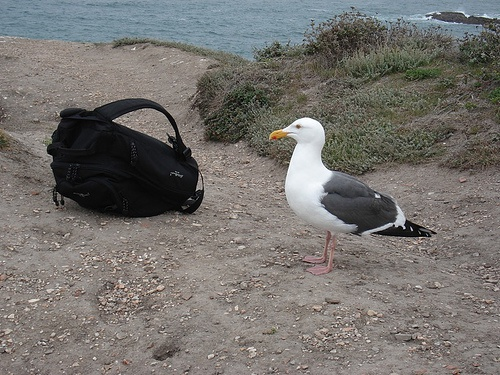Describe the objects in this image and their specific colors. I can see backpack in gray, black, and darkgray tones and bird in gray, lightgray, black, and darkgray tones in this image. 